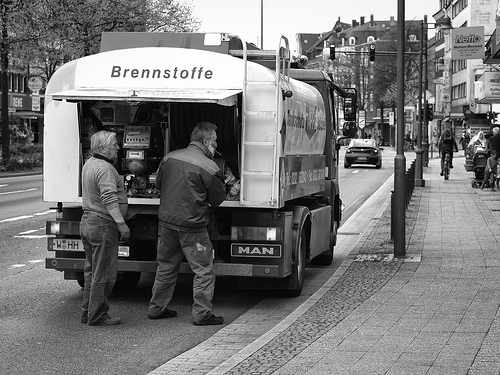Is there any indication of the time period this photo was taken? The photo is in black and white, which doesn't necessarily indicate it's old since modern photos can be filtered that way. However, the attire of the individuals, the vehicle's design with a registration plate that looks like older European styles, and the lack of modern cars or technology in view could suggest this image is from several decades ago. Without more context or color cues, it's difficult to accurately determine the exact time period. 